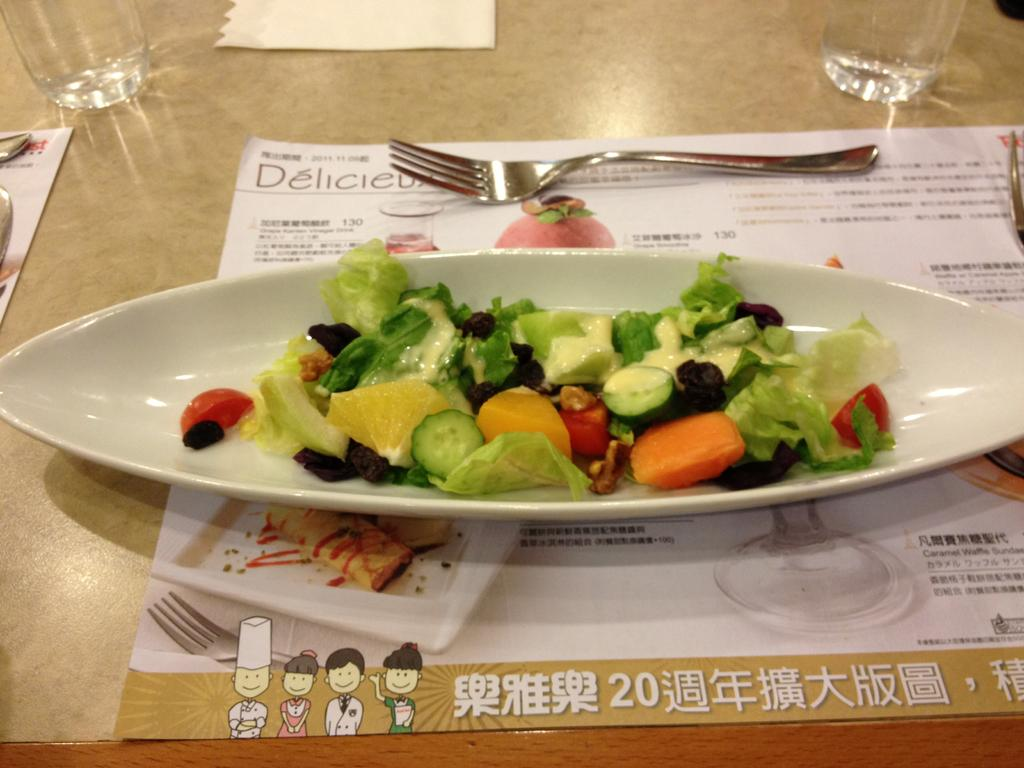What type of food is in the dish that is visible in the image? There is a salad dish in the image. How is the salad dish presented? The salad dish is kept in a plate. Where is the plate with the salad dish located? The plate with the salad dish is on a menu card. What is the menu card placed on? The menu card is on a table. What utensil is present on the table? There is a fork on the table. What type of tableware is present on the table? There are glasses on the table. What is used for cleaning or wiping on the table? There is tissue paper on the table. How many spiders are crawling on the salad dish in the image? There are no spiders present in the image; it only shows a salad dish in a plate. What type of land is visible in the image? The image does not depict any land; it shows a salad dish on a table. 